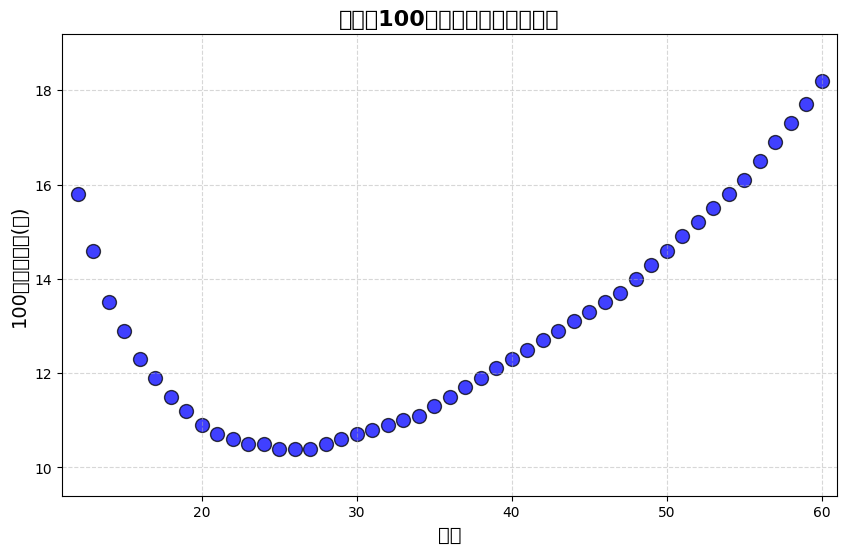How does the sprint time trend change between the ages of 12 to 20? By examining the scatter plot, we observe that the sprint time decreases steadily from 15.8 seconds at age 12 to 10.9 seconds at age 20, indicating an improvement in sprint speed as age increases in this range.
Answer: It decreases What is the fastest sprint time recorded on the plot, and at what age is it observed? The lowest point on the '100米短跑速度(秒)' axis represents the fastest time. From the scatter plot, the fastest time is 10.4 seconds, which is observed at ages 25, 26, and 27.
Answer: 10.4 seconds at ages 25, 26, and 27 At what age do we see the first increase in sprint time after several decreases? From the plot, the sprint time consistently decreases until it reaches 10.4 seconds at age 25 and 26. It starts to increase at age 28, with a time of 10.5 seconds.
Answer: Age 28 Compare the sprint times of a 14-year-old and a 40-year-old. Which one is faster, and by how much? From the scatter plot, the sprint time for a 14-year-old is 13.5 seconds, and for a 40-year-old it’s 12.3 seconds. To find the difference: 13.5 - 12.3 = 1.2 seconds. A 14-year-old is slower by 1.2 seconds.
Answer: 14-year-old by 1.2 seconds Which age group shows no change in 100米短跑速度(秒) and for how long does this last? By checking the ages on the x-axis and corresponding times on the y-axis, we observe that from ages 24 to 27, sprint times are constant at 10.4 seconds. This shows no change for 4 years.
Answer: Ages 24 to 27 for 4 years What can you infer about the sprint times of individuals aged 50 and above? By looking at the scatter plot points for ages 50 and above, we notice that the sprint times steadily increase from 14.6 seconds at age 50 to 18.2 seconds at age 60, indicating a decline in sprint speed with age.
Answer: Times increase steadily How does the sprint time for a 16-year-old compare to that of a 32-year-old? From the plot, a 16-year-old has a sprint time of 12.3 seconds, while a 32-year-old has a time of 10.9 seconds. Comparing these, the difference is 12.3 - 10.9 = 1.4 seconds. The 16-year-old is slower by 1.4 seconds.
Answer: 16-year-old is slower by 1.4 seconds What is the overall trend in sprint times as age increases from 12 to 60? Observing the general pattern on the scatter plot, sprint times initially decrease from ages 12 to about 25, indicating increased speed. After this, there’s a plateau followed by a gradual increase in sprint times, indicating decreased speed as age approaches 60.
Answer: Decreasing, then plateau, then increasing 